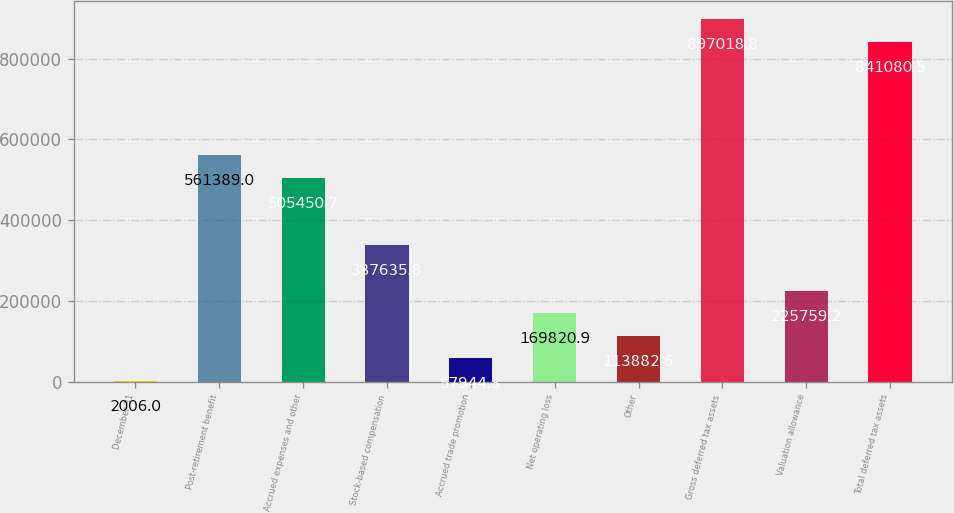Convert chart to OTSL. <chart><loc_0><loc_0><loc_500><loc_500><bar_chart><fcel>December 31<fcel>Post-retirement benefit<fcel>Accrued expenses and other<fcel>Stock-based compensation<fcel>Accrued trade promotion<fcel>Net operating loss<fcel>Other<fcel>Gross deferred tax assets<fcel>Valuation allowance<fcel>Total deferred tax assets<nl><fcel>2006<fcel>561389<fcel>505451<fcel>337636<fcel>57944.3<fcel>169821<fcel>113883<fcel>897019<fcel>225759<fcel>841080<nl></chart> 